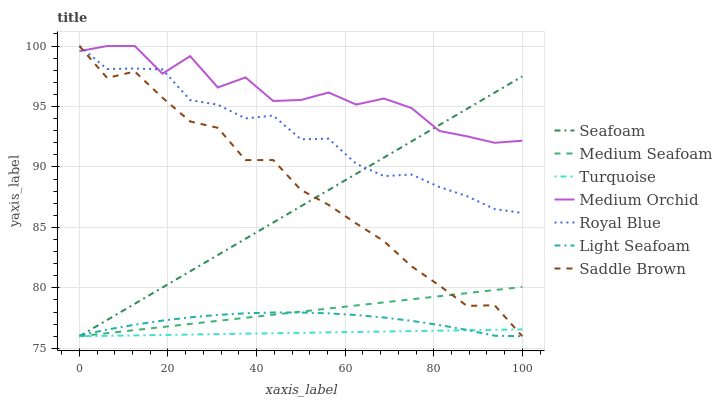Does Turquoise have the minimum area under the curve?
Answer yes or no. Yes. Does Medium Orchid have the maximum area under the curve?
Answer yes or no. Yes. Does Seafoam have the minimum area under the curve?
Answer yes or no. No. Does Seafoam have the maximum area under the curve?
Answer yes or no. No. Is Turquoise the smoothest?
Answer yes or no. Yes. Is Medium Orchid the roughest?
Answer yes or no. Yes. Is Seafoam the smoothest?
Answer yes or no. No. Is Seafoam the roughest?
Answer yes or no. No. Does Medium Orchid have the lowest value?
Answer yes or no. No. Does Seafoam have the highest value?
Answer yes or no. No. Is Turquoise less than Medium Orchid?
Answer yes or no. Yes. Is Royal Blue greater than Light Seafoam?
Answer yes or no. Yes. Does Turquoise intersect Medium Orchid?
Answer yes or no. No. 